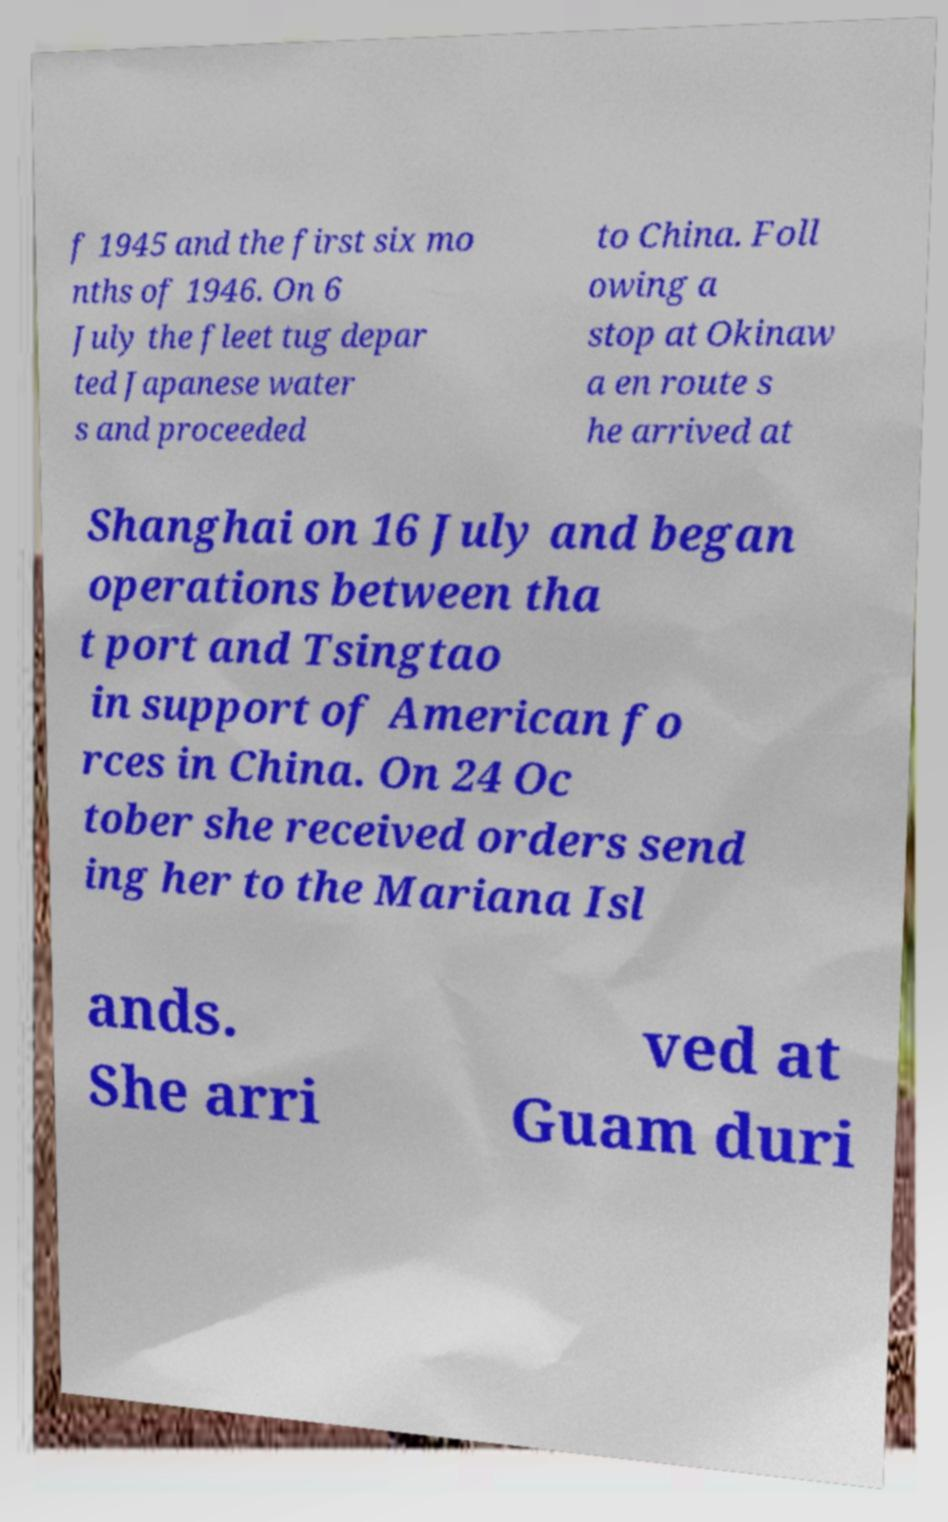For documentation purposes, I need the text within this image transcribed. Could you provide that? f 1945 and the first six mo nths of 1946. On 6 July the fleet tug depar ted Japanese water s and proceeded to China. Foll owing a stop at Okinaw a en route s he arrived at Shanghai on 16 July and began operations between tha t port and Tsingtao in support of American fo rces in China. On 24 Oc tober she received orders send ing her to the Mariana Isl ands. She arri ved at Guam duri 